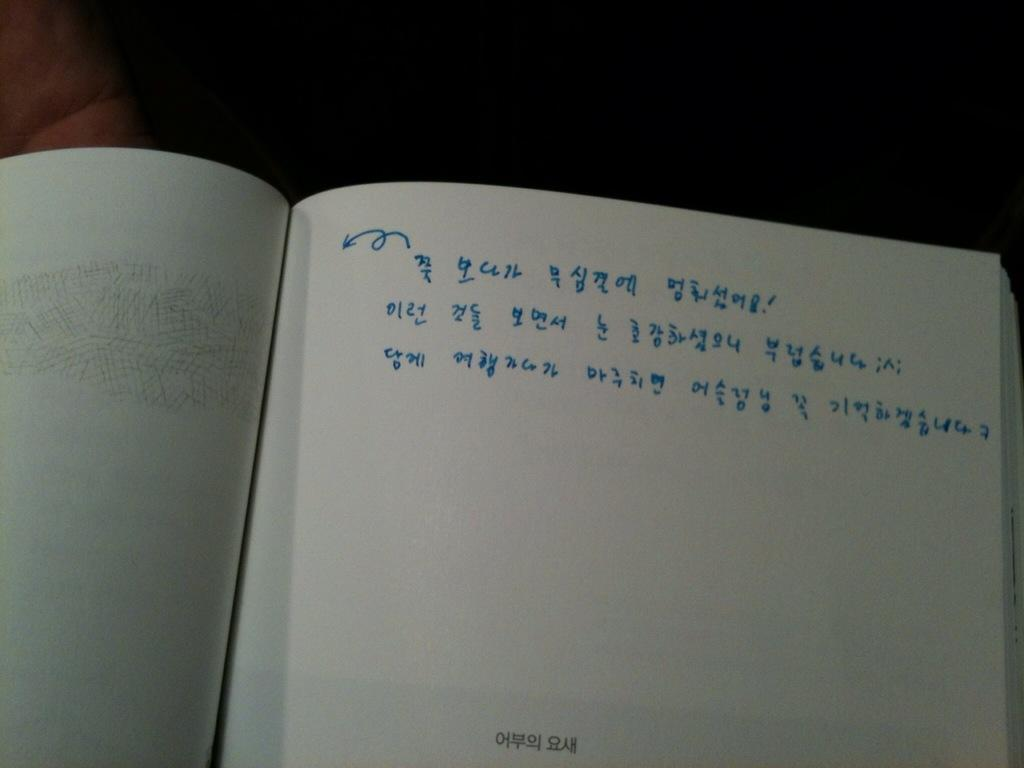<image>
Give a short and clear explanation of the subsequent image. A squiggly arrow in blue ink next to some kind of text in a language I'm not familiar with. 